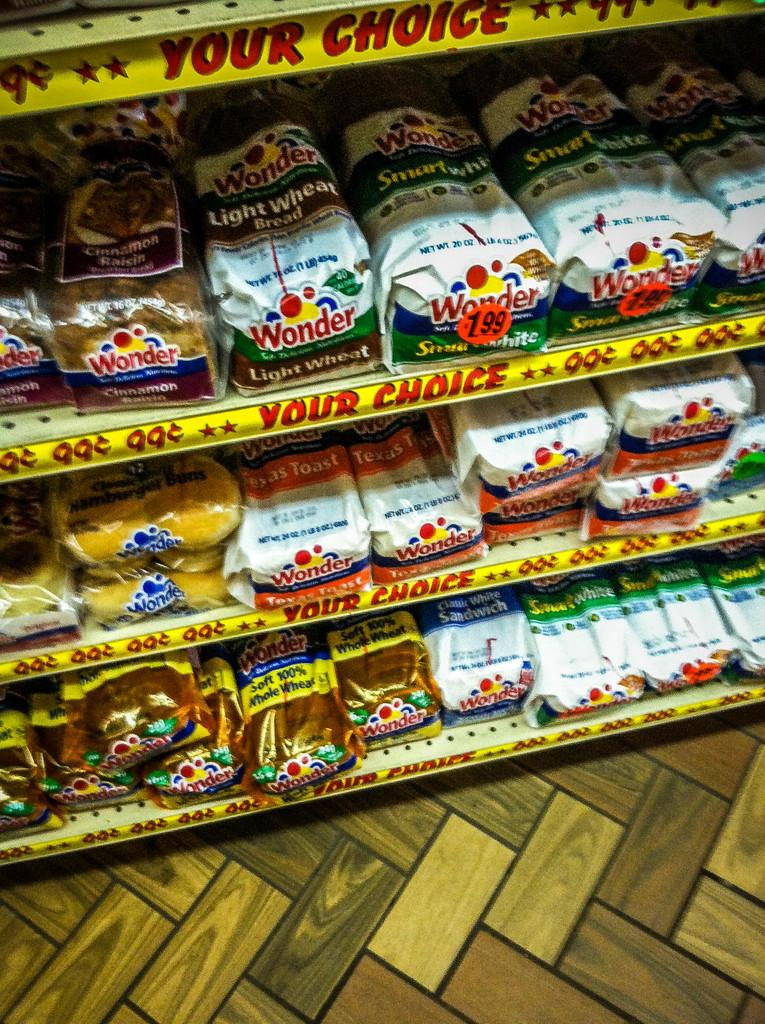<image>
Present a compact description of the photo's key features. Bread aisle showing many breads and one for 1.99 